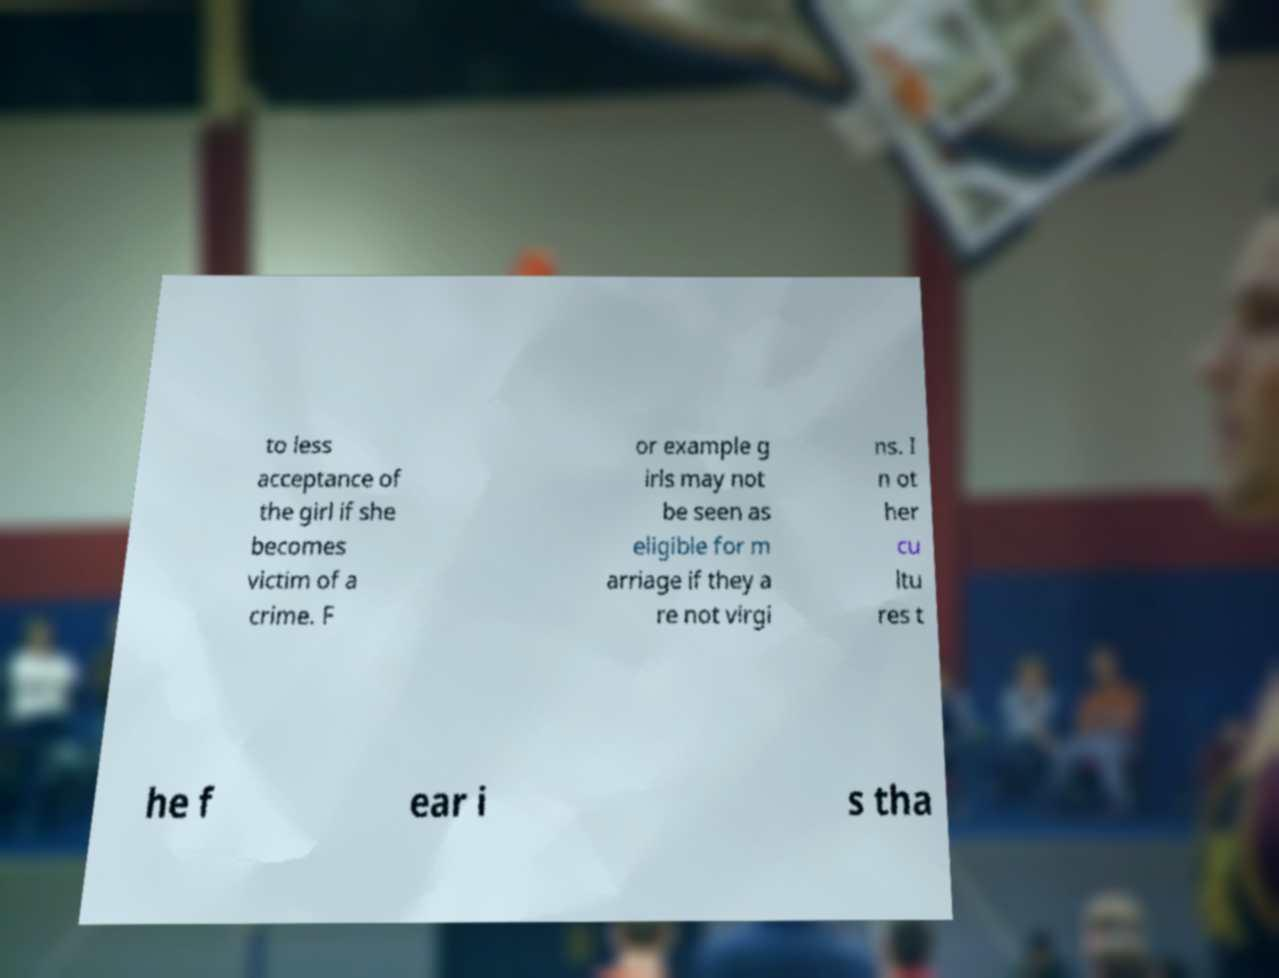Please read and relay the text visible in this image. What does it say? to less acceptance of the girl if she becomes victim of a crime. F or example g irls may not be seen as eligible for m arriage if they a re not virgi ns. I n ot her cu ltu res t he f ear i s tha 